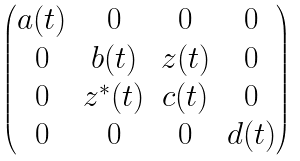Convert formula to latex. <formula><loc_0><loc_0><loc_500><loc_500>\begin{pmatrix} a ( t ) & 0 & 0 & 0 \\ 0 & b ( t ) & z ( t ) & 0 \\ 0 & z ^ { * } ( t ) & c ( t ) & 0 \\ 0 & 0 & 0 & d ( t ) \end{pmatrix}</formula> 